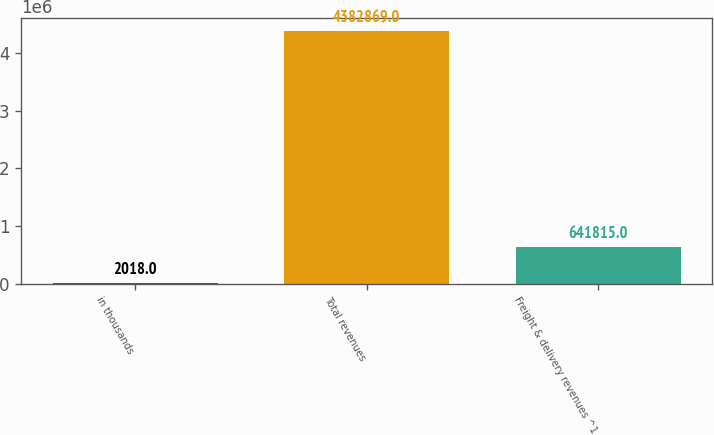Convert chart to OTSL. <chart><loc_0><loc_0><loc_500><loc_500><bar_chart><fcel>in thousands<fcel>Total revenues<fcel>Freight & delivery revenues ^1<nl><fcel>2018<fcel>4.38287e+06<fcel>641815<nl></chart> 